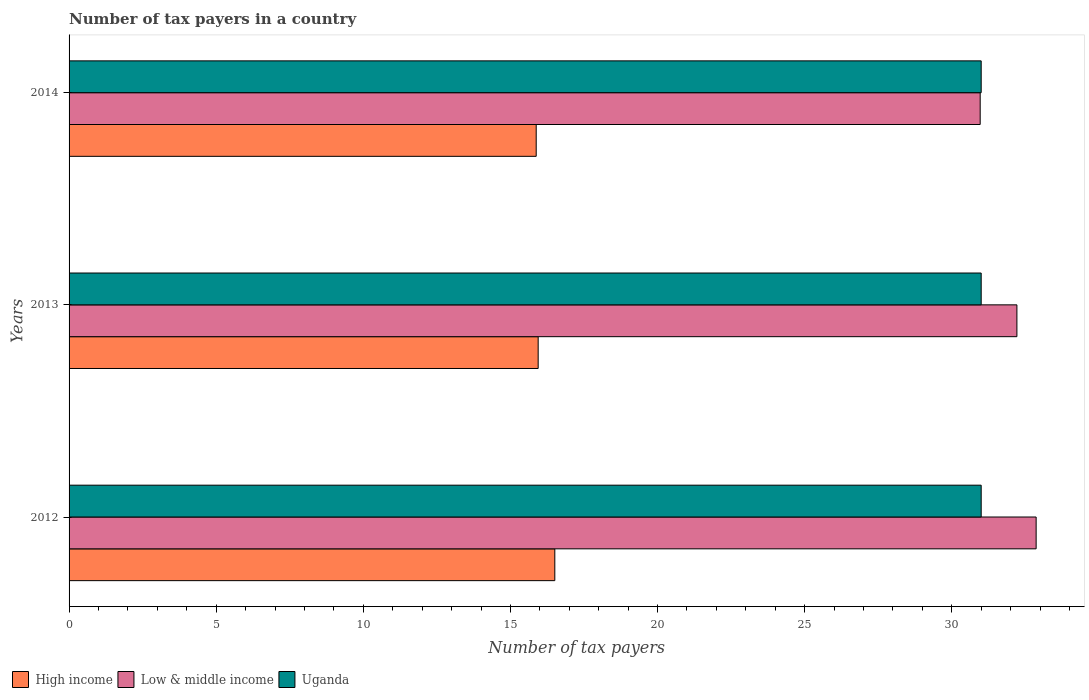How many different coloured bars are there?
Provide a succinct answer. 3. How many bars are there on the 2nd tick from the top?
Give a very brief answer. 3. How many bars are there on the 1st tick from the bottom?
Offer a very short reply. 3. What is the label of the 1st group of bars from the top?
Make the answer very short. 2014. What is the number of tax payers in in Uganda in 2014?
Provide a succinct answer. 31. Across all years, what is the maximum number of tax payers in in Uganda?
Your response must be concise. 31. Across all years, what is the minimum number of tax payers in in Uganda?
Make the answer very short. 31. In which year was the number of tax payers in in Uganda minimum?
Provide a short and direct response. 2012. What is the total number of tax payers in in High income in the graph?
Keep it short and to the point. 48.33. What is the difference between the number of tax payers in in Uganda in 2013 and that in 2014?
Provide a succinct answer. 0. What is the difference between the number of tax payers in in Uganda in 2013 and the number of tax payers in in High income in 2012?
Offer a terse response. 14.49. In the year 2013, what is the difference between the number of tax payers in in High income and number of tax payers in in Low & middle income?
Offer a terse response. -16.27. In how many years, is the number of tax payers in in Low & middle income greater than 23 ?
Offer a very short reply. 3. What is the ratio of the number of tax payers in in High income in 2012 to that in 2014?
Give a very brief answer. 1.04. What is the difference between the highest and the second highest number of tax payers in in High income?
Offer a very short reply. 0.57. What is the difference between the highest and the lowest number of tax payers in in Uganda?
Your response must be concise. 0. Is it the case that in every year, the sum of the number of tax payers in in Uganda and number of tax payers in in Low & middle income is greater than the number of tax payers in in High income?
Offer a very short reply. Yes. How many bars are there?
Keep it short and to the point. 9. How many years are there in the graph?
Offer a terse response. 3. Are the values on the major ticks of X-axis written in scientific E-notation?
Your answer should be very brief. No. How are the legend labels stacked?
Give a very brief answer. Horizontal. What is the title of the graph?
Give a very brief answer. Number of tax payers in a country. What is the label or title of the X-axis?
Ensure brevity in your answer.  Number of tax payers. What is the Number of tax payers in High income in 2012?
Provide a succinct answer. 16.51. What is the Number of tax payers in Low & middle income in 2012?
Your answer should be compact. 32.87. What is the Number of tax payers in Uganda in 2012?
Offer a terse response. 31. What is the Number of tax payers of High income in 2013?
Offer a terse response. 15.94. What is the Number of tax payers in Low & middle income in 2013?
Offer a terse response. 32.21. What is the Number of tax payers of Uganda in 2013?
Ensure brevity in your answer.  31. What is the Number of tax payers in High income in 2014?
Keep it short and to the point. 15.88. What is the Number of tax payers in Low & middle income in 2014?
Offer a terse response. 30.97. Across all years, what is the maximum Number of tax payers of High income?
Provide a short and direct response. 16.51. Across all years, what is the maximum Number of tax payers of Low & middle income?
Ensure brevity in your answer.  32.87. Across all years, what is the minimum Number of tax payers of High income?
Ensure brevity in your answer.  15.88. Across all years, what is the minimum Number of tax payers of Low & middle income?
Your answer should be very brief. 30.97. Across all years, what is the minimum Number of tax payers in Uganda?
Make the answer very short. 31. What is the total Number of tax payers of High income in the graph?
Your answer should be compact. 48.33. What is the total Number of tax payers of Low & middle income in the graph?
Offer a terse response. 96.05. What is the total Number of tax payers in Uganda in the graph?
Provide a succinct answer. 93. What is the difference between the Number of tax payers of High income in 2012 and that in 2013?
Make the answer very short. 0.57. What is the difference between the Number of tax payers in Low & middle income in 2012 and that in 2013?
Your answer should be very brief. 0.65. What is the difference between the Number of tax payers in High income in 2012 and that in 2014?
Provide a succinct answer. 0.63. What is the difference between the Number of tax payers in Low & middle income in 2012 and that in 2014?
Your answer should be very brief. 1.9. What is the difference between the Number of tax payers of Uganda in 2012 and that in 2014?
Keep it short and to the point. 0. What is the difference between the Number of tax payers in High income in 2013 and that in 2014?
Ensure brevity in your answer.  0.07. What is the difference between the Number of tax payers of Low & middle income in 2013 and that in 2014?
Make the answer very short. 1.25. What is the difference between the Number of tax payers in High income in 2012 and the Number of tax payers in Low & middle income in 2013?
Offer a terse response. -15.71. What is the difference between the Number of tax payers of High income in 2012 and the Number of tax payers of Uganda in 2013?
Give a very brief answer. -14.49. What is the difference between the Number of tax payers in Low & middle income in 2012 and the Number of tax payers in Uganda in 2013?
Provide a short and direct response. 1.87. What is the difference between the Number of tax payers of High income in 2012 and the Number of tax payers of Low & middle income in 2014?
Make the answer very short. -14.46. What is the difference between the Number of tax payers of High income in 2012 and the Number of tax payers of Uganda in 2014?
Your answer should be compact. -14.49. What is the difference between the Number of tax payers of Low & middle income in 2012 and the Number of tax payers of Uganda in 2014?
Keep it short and to the point. 1.87. What is the difference between the Number of tax payers in High income in 2013 and the Number of tax payers in Low & middle income in 2014?
Keep it short and to the point. -15.02. What is the difference between the Number of tax payers of High income in 2013 and the Number of tax payers of Uganda in 2014?
Give a very brief answer. -15.06. What is the difference between the Number of tax payers in Low & middle income in 2013 and the Number of tax payers in Uganda in 2014?
Provide a succinct answer. 1.21. What is the average Number of tax payers of High income per year?
Make the answer very short. 16.11. What is the average Number of tax payers of Low & middle income per year?
Offer a very short reply. 32.02. What is the average Number of tax payers in Uganda per year?
Keep it short and to the point. 31. In the year 2012, what is the difference between the Number of tax payers of High income and Number of tax payers of Low & middle income?
Provide a succinct answer. -16.36. In the year 2012, what is the difference between the Number of tax payers in High income and Number of tax payers in Uganda?
Keep it short and to the point. -14.49. In the year 2012, what is the difference between the Number of tax payers of Low & middle income and Number of tax payers of Uganda?
Your response must be concise. 1.87. In the year 2013, what is the difference between the Number of tax payers in High income and Number of tax payers in Low & middle income?
Give a very brief answer. -16.27. In the year 2013, what is the difference between the Number of tax payers in High income and Number of tax payers in Uganda?
Offer a terse response. -15.06. In the year 2013, what is the difference between the Number of tax payers in Low & middle income and Number of tax payers in Uganda?
Offer a very short reply. 1.21. In the year 2014, what is the difference between the Number of tax payers of High income and Number of tax payers of Low & middle income?
Your response must be concise. -15.09. In the year 2014, what is the difference between the Number of tax payers in High income and Number of tax payers in Uganda?
Your response must be concise. -15.12. In the year 2014, what is the difference between the Number of tax payers in Low & middle income and Number of tax payers in Uganda?
Offer a terse response. -0.03. What is the ratio of the Number of tax payers of High income in 2012 to that in 2013?
Your response must be concise. 1.04. What is the ratio of the Number of tax payers of Low & middle income in 2012 to that in 2013?
Provide a succinct answer. 1.02. What is the ratio of the Number of tax payers in High income in 2012 to that in 2014?
Ensure brevity in your answer.  1.04. What is the ratio of the Number of tax payers of Low & middle income in 2012 to that in 2014?
Offer a very short reply. 1.06. What is the ratio of the Number of tax payers in Uganda in 2012 to that in 2014?
Ensure brevity in your answer.  1. What is the ratio of the Number of tax payers in High income in 2013 to that in 2014?
Your answer should be very brief. 1. What is the ratio of the Number of tax payers of Low & middle income in 2013 to that in 2014?
Offer a very short reply. 1.04. What is the difference between the highest and the second highest Number of tax payers of High income?
Ensure brevity in your answer.  0.57. What is the difference between the highest and the second highest Number of tax payers in Low & middle income?
Give a very brief answer. 0.65. What is the difference between the highest and the second highest Number of tax payers in Uganda?
Your response must be concise. 0. What is the difference between the highest and the lowest Number of tax payers of High income?
Your response must be concise. 0.63. What is the difference between the highest and the lowest Number of tax payers in Low & middle income?
Your answer should be compact. 1.9. 